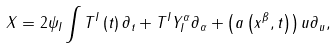<formula> <loc_0><loc_0><loc_500><loc_500>X = 2 \psi _ { I } \int T ^ { I } \left ( t \right ) \partial _ { t } + T ^ { I } Y _ { I } ^ { \alpha } \partial _ { \alpha } + \left ( a \left ( x ^ { \beta } , t \right ) \right ) u \partial _ { u } ,</formula> 